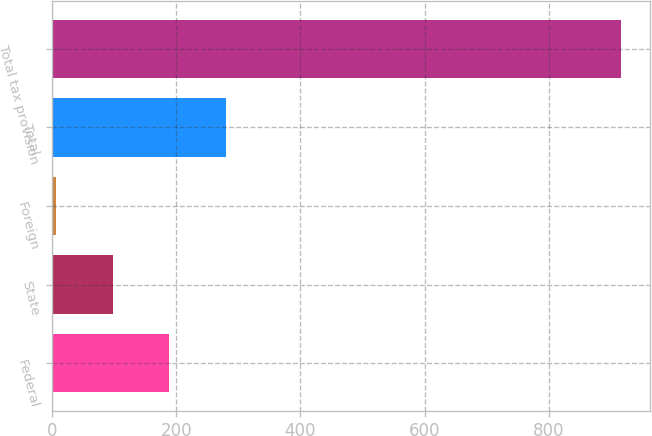Convert chart. <chart><loc_0><loc_0><loc_500><loc_500><bar_chart><fcel>Federal<fcel>State<fcel>Foreign<fcel>Total<fcel>Total tax provision<nl><fcel>188.2<fcel>97.1<fcel>6<fcel>279.3<fcel>917<nl></chart> 